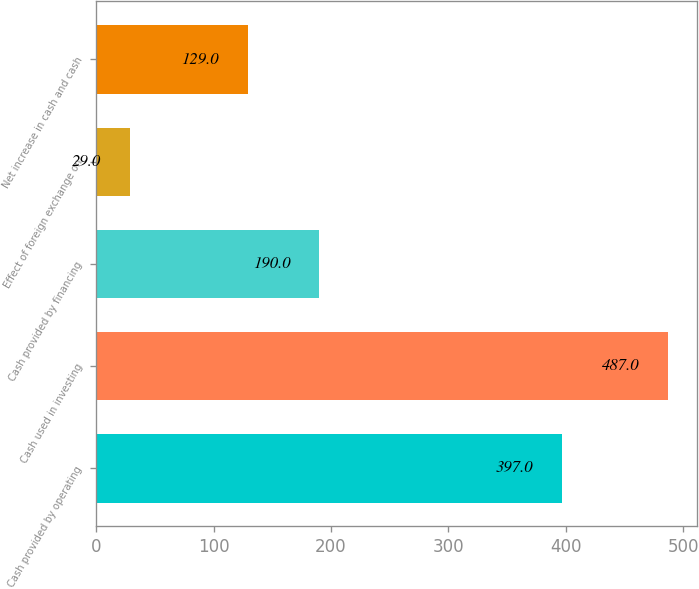Convert chart to OTSL. <chart><loc_0><loc_0><loc_500><loc_500><bar_chart><fcel>Cash provided by operating<fcel>Cash used in investing<fcel>Cash provided by financing<fcel>Effect of foreign exchange on<fcel>Net increase in cash and cash<nl><fcel>397<fcel>487<fcel>190<fcel>29<fcel>129<nl></chart> 